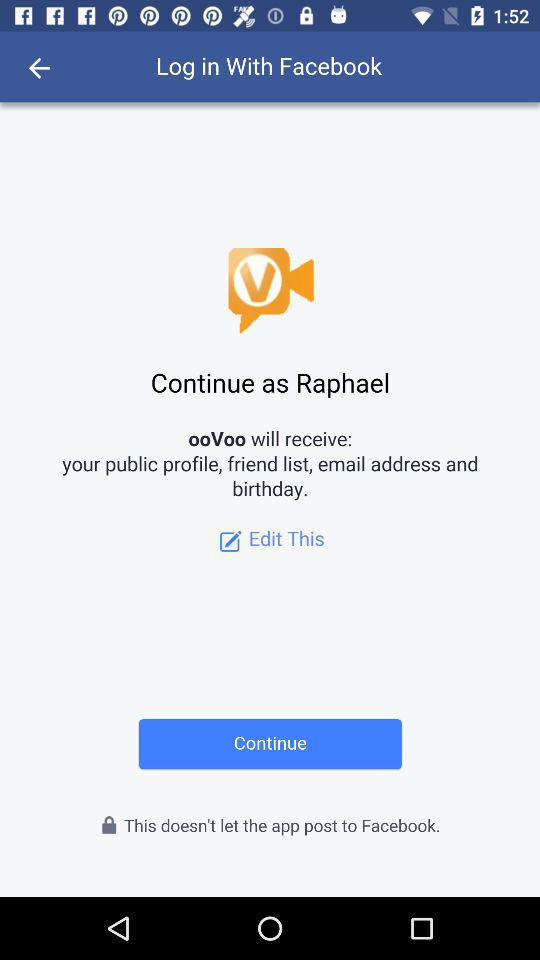What application is asking for permission? The application is "ooVoo". 